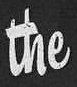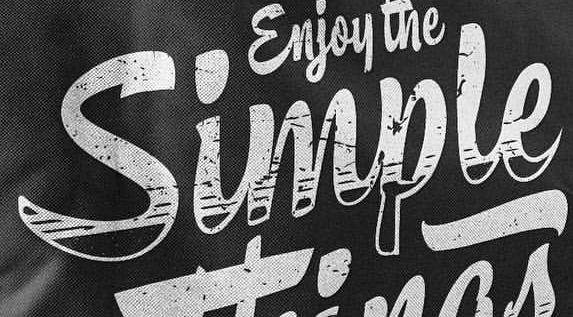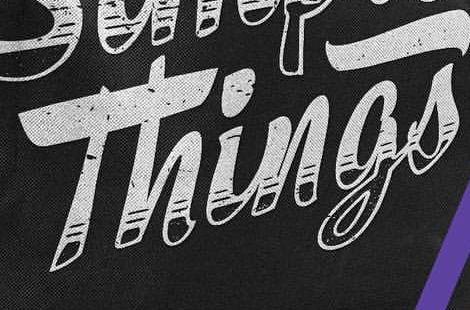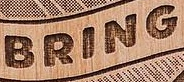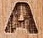What words are shown in these images in order, separated by a semicolon? the; Simple; Things; BRING; A 